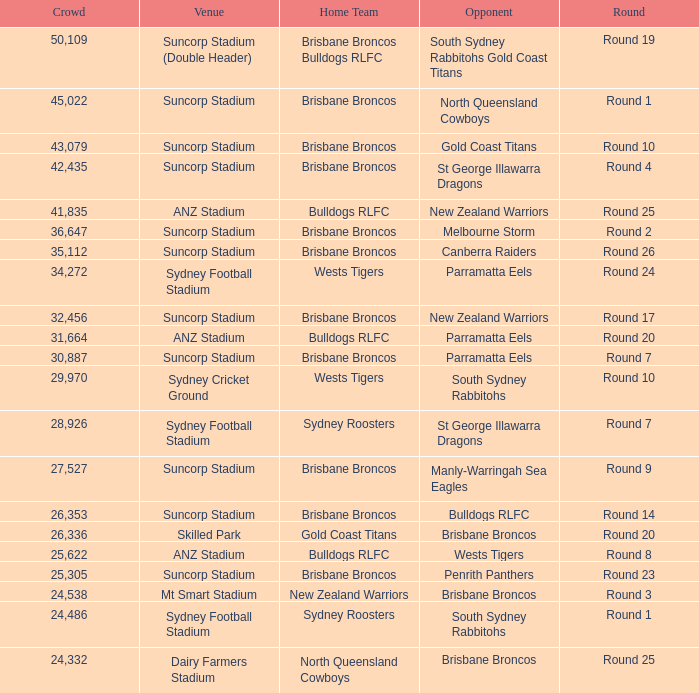What was the turnout for round 9? 1.0. 